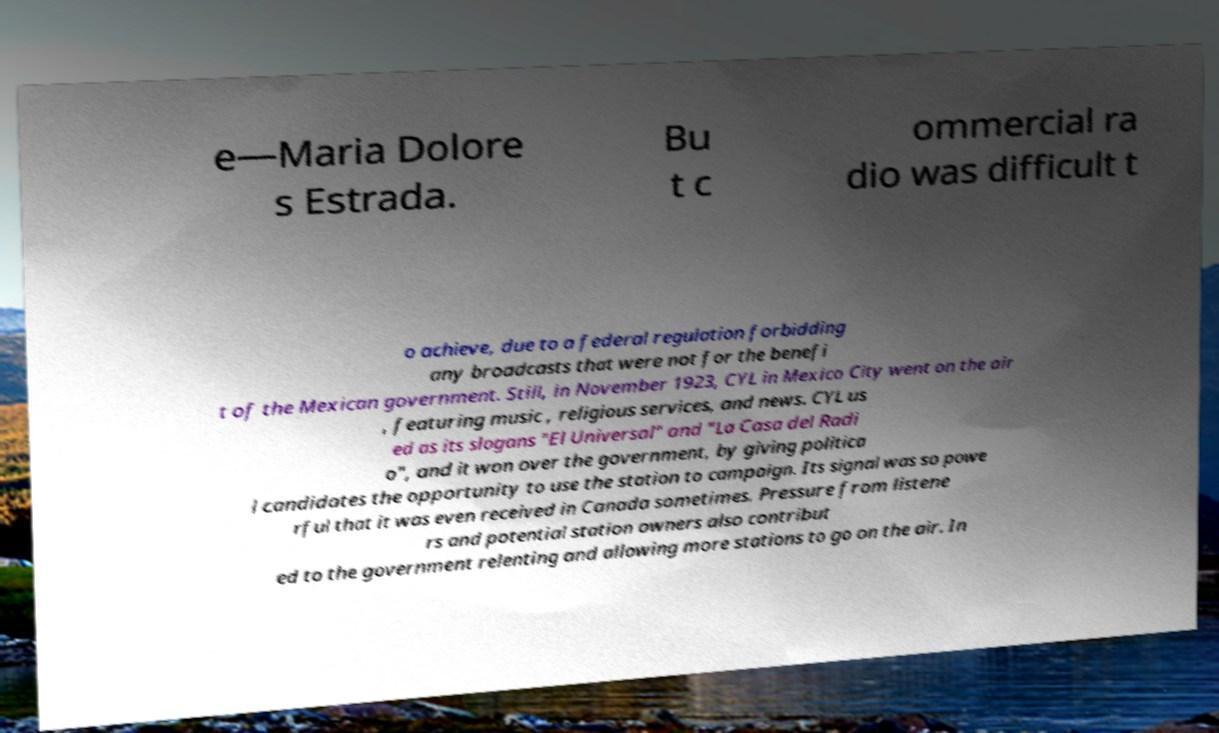Can you accurately transcribe the text from the provided image for me? e—Maria Dolore s Estrada. Bu t c ommercial ra dio was difficult t o achieve, due to a federal regulation forbidding any broadcasts that were not for the benefi t of the Mexican government. Still, in November 1923, CYL in Mexico City went on the air , featuring music , religious services, and news. CYL us ed as its slogans "El Universal" and "La Casa del Radi o", and it won over the government, by giving politica l candidates the opportunity to use the station to campaign. Its signal was so powe rful that it was even received in Canada sometimes. Pressure from listene rs and potential station owners also contribut ed to the government relenting and allowing more stations to go on the air. In 